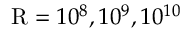Convert formula to latex. <formula><loc_0><loc_0><loc_500><loc_500>R = 1 0 ^ { 8 } , 1 0 ^ { 9 } , 1 0 ^ { 1 0 }</formula> 